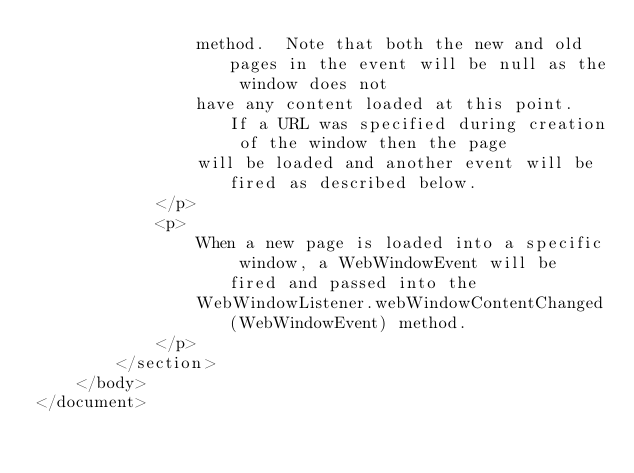Convert code to text. <code><loc_0><loc_0><loc_500><loc_500><_XML_>                method.  Note that both the new and old pages in the event will be null as the window does not
                have any content loaded at this point.  If a URL was specified during creation of the window then the page
                will be loaded and another event will be fired as described below.
            </p>
            <p>
                When a new page is loaded into a specific window, a WebWindowEvent will be fired and passed into the
                WebWindowListener.webWindowContentChanged(WebWindowEvent) method.
            </p>
        </section>
    </body>
</document>

</code> 